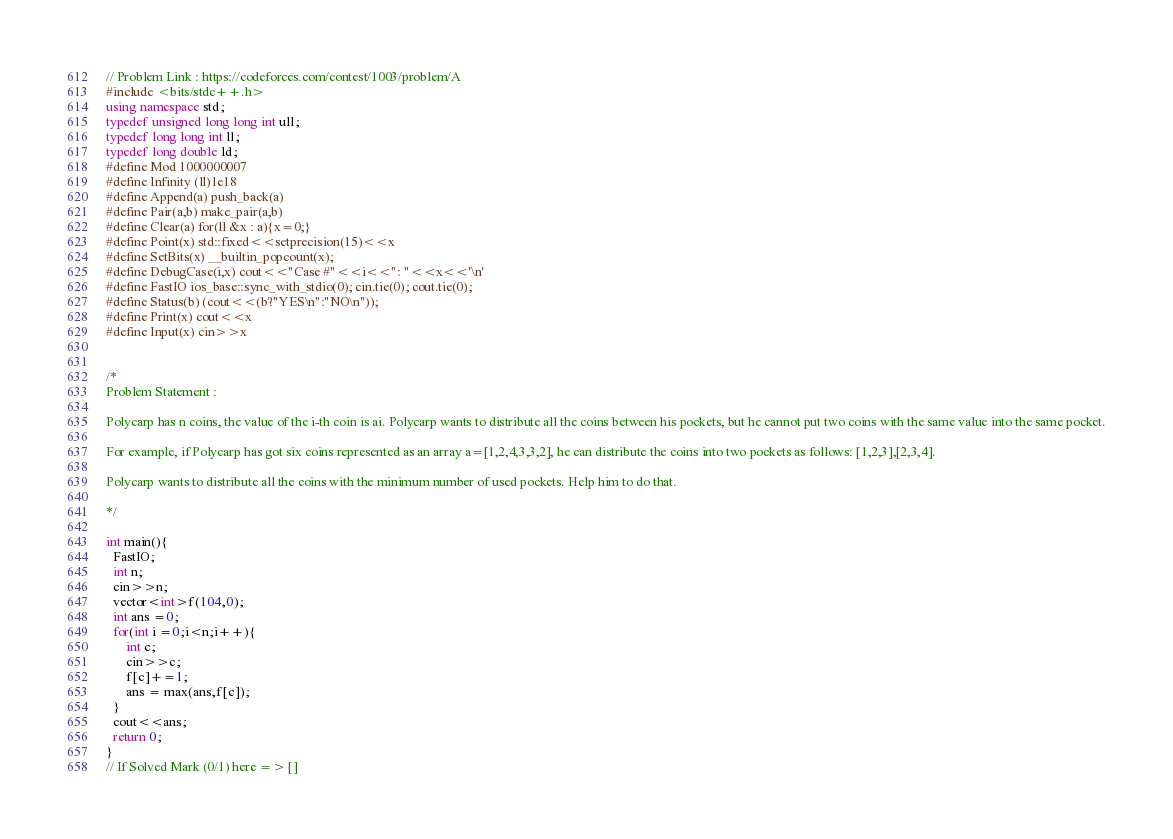<code> <loc_0><loc_0><loc_500><loc_500><_C++_>// Problem Link : https://codeforces.com/contest/1003/problem/A
#include <bits/stdc++.h>
using namespace std;
typedef unsigned long long int ull;
typedef long long int ll;
typedef long double ld;
#define Mod 1000000007
#define Infinity (ll)1e18
#define Append(a) push_back(a)
#define Pair(a,b) make_pair(a,b)
#define Clear(a) for(ll &x : a){x=0;}
#define Point(x) std::fixed<<setprecision(15)<<x
#define SetBits(x) __builtin_popcount(x);
#define DebugCase(i,x) cout<<"Case #"<<i<<": "<<x<<'\n'
#define FastIO ios_base::sync_with_stdio(0); cin.tie(0); cout.tie(0);
#define Status(b) (cout<<(b?"YES\n":"NO\n"));
#define Print(x) cout<<x
#define Input(x) cin>>x


/*
Problem Statement : 

Polycarp has n coins, the value of the i-th coin is ai. Polycarp wants to distribute all the coins between his pockets, but he cannot put two coins with the same value into the same pocket.

For example, if Polycarp has got six coins represented as an array a=[1,2,4,3,3,2], he can distribute the coins into two pockets as follows: [1,2,3],[2,3,4].

Polycarp wants to distribute all the coins with the minimum number of used pockets. Help him to do that.

*/

int main(){
  FastIO;
  int n;
  cin>>n;
  vector<int>f(104,0);
  int ans =0;
  for(int i =0;i<n;i++){
      int c;
      cin>>c;
      f[c]+=1;
      ans = max(ans,f[c]);
  }
  cout<<ans;
  return 0;
} 
// If Solved Mark (0/1) here => []</code> 